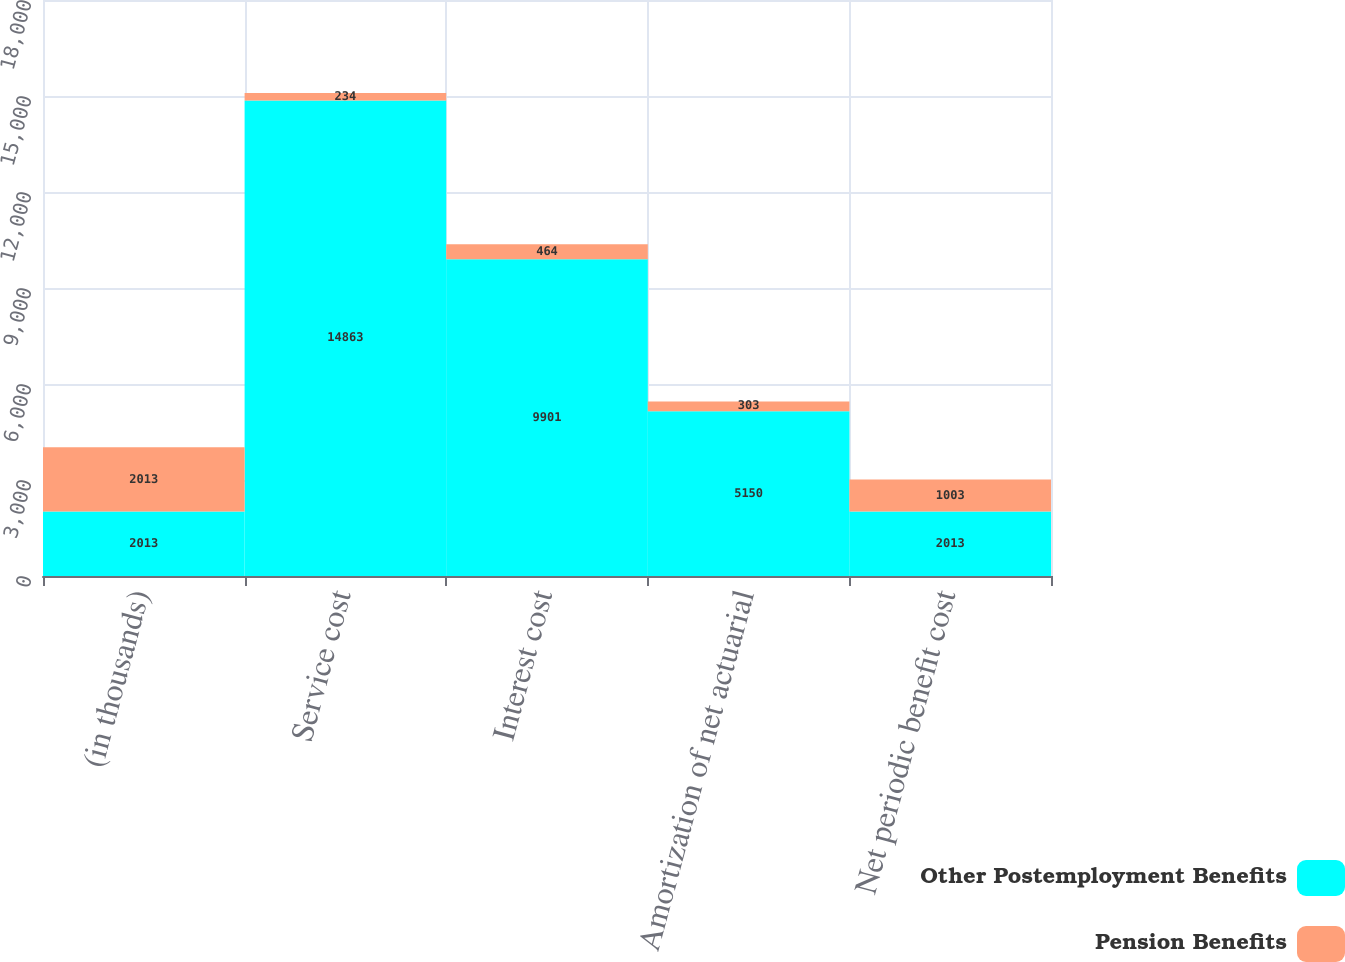Convert chart. <chart><loc_0><loc_0><loc_500><loc_500><stacked_bar_chart><ecel><fcel>(in thousands)<fcel>Service cost<fcel>Interest cost<fcel>Amortization of net actuarial<fcel>Net periodic benefit cost<nl><fcel>Other Postemployment Benefits<fcel>2013<fcel>14863<fcel>9901<fcel>5150<fcel>2013<nl><fcel>Pension Benefits<fcel>2013<fcel>234<fcel>464<fcel>303<fcel>1003<nl></chart> 